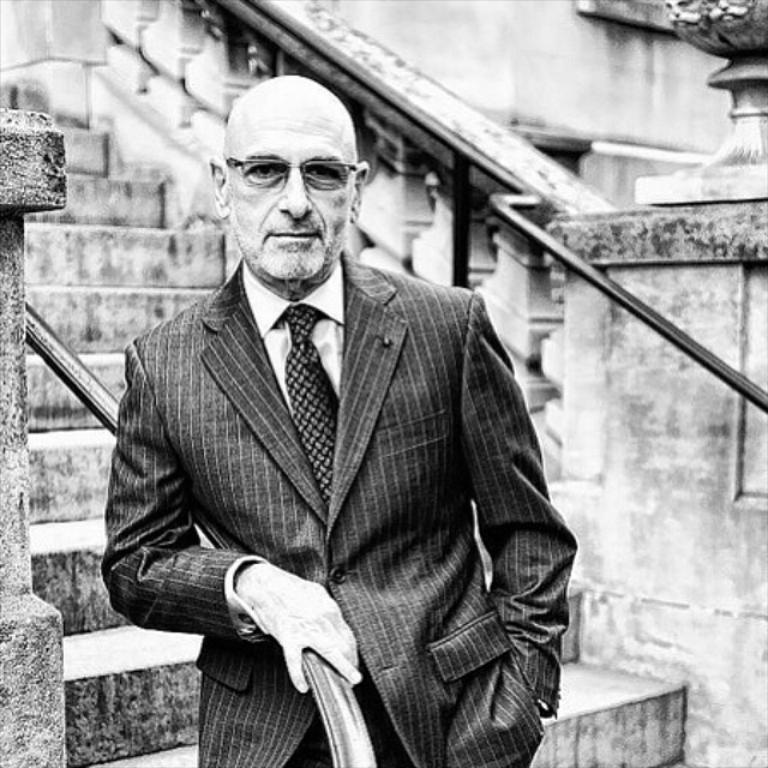What is the main subject of the image? There is a man standing in the image. What is the man wearing in the image? The man is wearing formal dress and glasses (specs) in the image. What can be seen in the background of the image? There are stairs in the background of the image. What is the color scheme of the image? The image is black and white in color. Can you hear the man whistling in the image? There is no indication of sound or whistling in the image, as it is a still photograph. Is there any visible dust on the man's formal dress in the image? There is no visible dust on the man's formal dress in the image; the image is black and white and does not show any dust particles. 